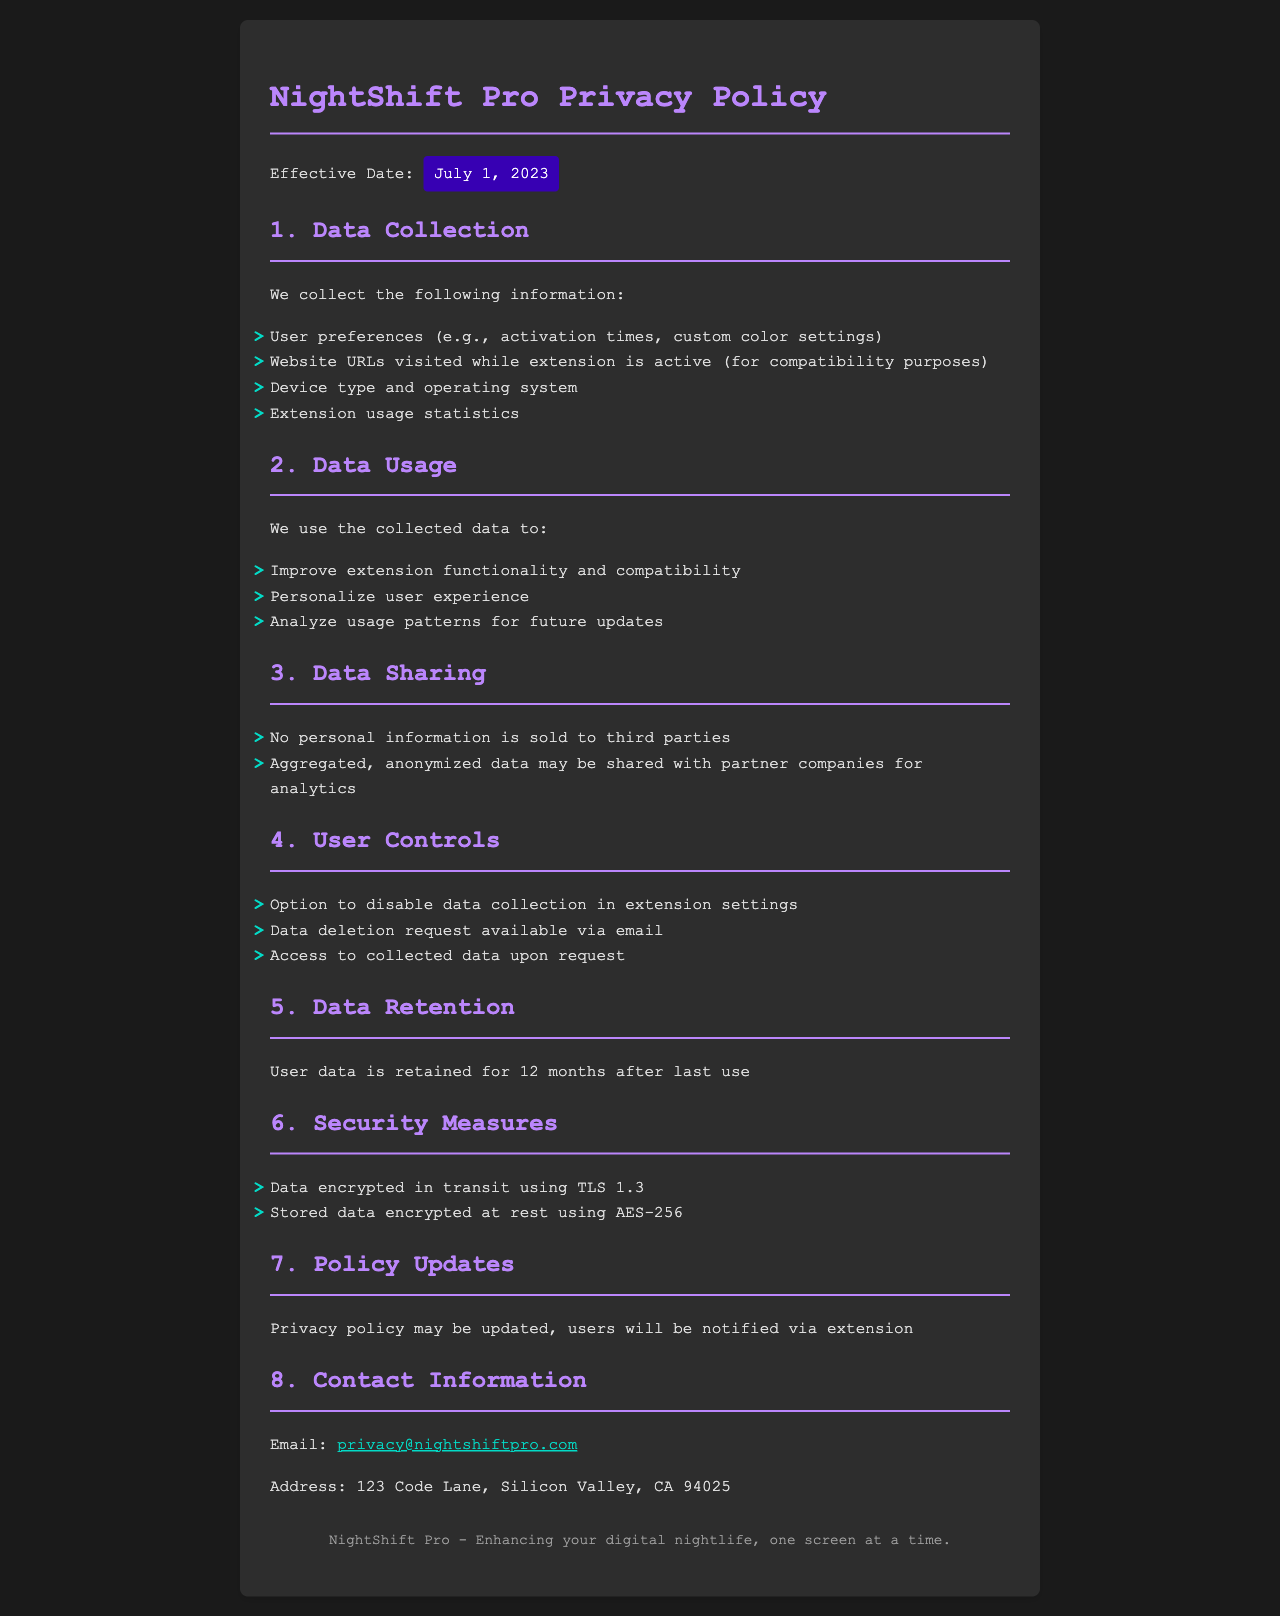What is the effective date of the privacy policy? The effective date is stated near the beginning of the document, which is July 1, 2023.
Answer: July 1, 2023 What types of data does the extension collect? The document lists specific types of collected data, including User preferences and Device type.
Answer: User preferences, website URLs, device type, extension usage statistics How long is user data retained? The retention period for user data is mentioned in the Data Retention section of the document.
Answer: 12 months What security measure is used for data in transit? The document specifies the security measure used for data in transit, which is TLS 1.3.
Answer: TLS 1.3 Is personal information sold to third parties? The Data Sharing section addresses this matter, specifically stating the policy regarding personal information.
Answer: No What options do users have to control their data? User Controls section outlines the specific controls available to users regarding their data.
Answer: Disable data collection, data deletion request, access collected data How is the collected data used? The Data Usage section explains how the collected data is intended to be utilized.
Answer: Improve functionality, personalize experience, analyze usage patterns How will users be notified of policy updates? The document states the method of notification for updates to the privacy policy.
Answer: Via extension 